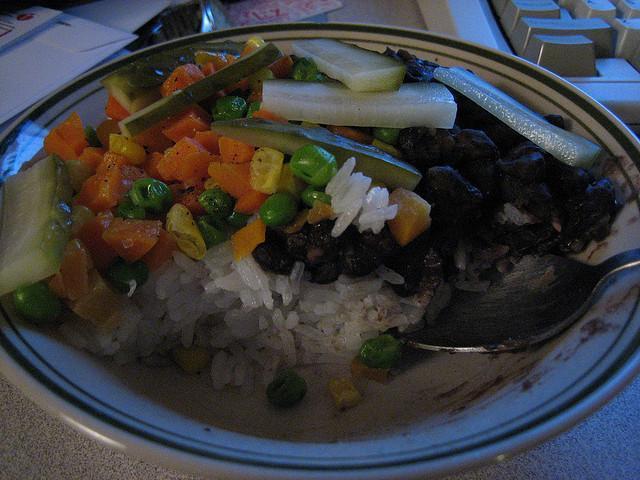How many spoons are there?
Give a very brief answer. 1. How many carrots are there?
Give a very brief answer. 2. How many brown horses are in the grass?
Give a very brief answer. 0. 